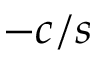<formula> <loc_0><loc_0><loc_500><loc_500>- c / s</formula> 